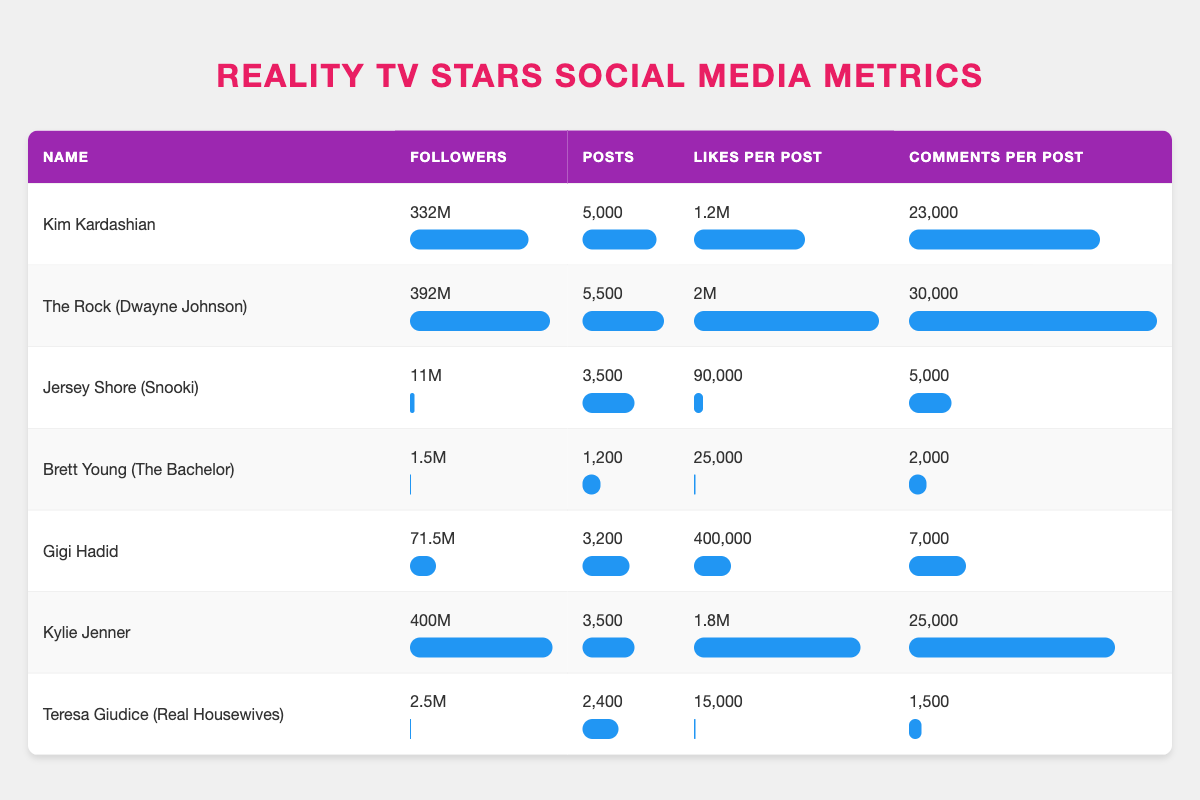What is the total number of posts made by Kim Kardashian? Kim Kardashian has made 5,000 posts. The value is stated directly in the table under the "Posts" column corresponding to her name.
Answer: 5,000 Which actor has the highest number of followers? The Rock (Dwayne Johnson) has the highest number of followers with 392 million. This is found by comparing the "Followers" column for all actors in the table.
Answer: The Rock (Dwayne Johnson) What is the average number of likes per post across all reality TV actors listed? To find the average, first, add the likes per post for all actors: (1.2M + 2M + 90K + 25K + 400K + 1.8M + 15K) = 4.920M. Then, divide by the number of actors (7): 4.920M / 7 = approximately 0.703M (or 703,000).
Answer: 703,000 Does Gigi Hadid have more followers than Snooki? Gigi Hadid has 71.5 million followers, whereas Snooki has 11 million followers. Since 71.5 million is greater than 11 million, Gigi Hadid does have more followers than Snooki.
Answer: Yes What is the difference in the number of likes per post between The Rock and Kylie Jenner? The Rock's likes per post are 2 million, and Kylie Jenner's are 1.8 million. The difference is calculated as 2M - 1.8M = 0.2M (or 200,000).
Answer: 200,000 Who has the lowest comments per post, and what is that value? Brett Young has the lowest comments per post with 2,000. This is identified by reading through the "Comments per Post" column and noting Brett Young's corresponding value.
Answer: 2,000 If we want to combine the followers of Teresa Giudice and Brett Young, how many followers would that total? Teresa Giudice has 2.5 million followers and Brett Young has 1.5 million. Adding these two values gives 2.5M + 1.5M = 4 million followers in total.
Answer: 4 million Which actor has the highest average engagement based on likes and comments together per post? First, calculate the engagement (likes + comments) per post for each actor, then compare: 
- Kim Kardashian: 1.2M + 23K = 1.223M 
- The Rock: 2M + 30K = 2.030M 
- Snooki: 90K + 5K = 95K 
- Brett Young: 25K + 2K = 27K 
- Gigi Hadid: 400K + 7K = 407K 
- Kylie Jenner: 1.8M + 25K = 1.825M 
- Teresa Giudice: 15K + 1.5K = 16.5K 
The highest is The Rock with 2.030 million.
Answer: The Rock (Dwayne Johnson) 